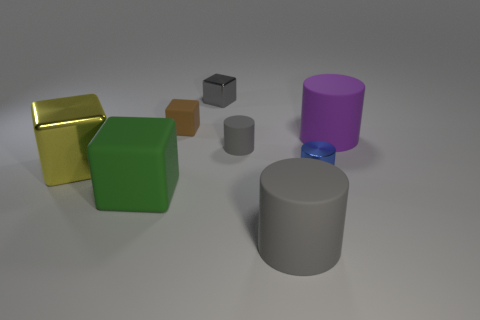There is a brown block that is the same material as the tiny gray cylinder; what size is it?
Give a very brief answer. Small. Is the shape of the small gray rubber thing the same as the tiny matte thing left of the small rubber cylinder?
Your answer should be very brief. No. What is the size of the blue metallic cylinder?
Ensure brevity in your answer.  Small. Is the number of big things that are right of the big green rubber thing less than the number of brown things?
Keep it short and to the point. No. What number of red metal things have the same size as the shiny cylinder?
Offer a very short reply. 0. There is a big thing that is the same color as the small metal cube; what shape is it?
Your answer should be compact. Cylinder. Does the big cylinder behind the big gray thing have the same color as the small thing that is on the left side of the small gray metallic thing?
Offer a terse response. No. There is a yellow object; how many metal cubes are behind it?
Your response must be concise. 1. The metallic cube that is the same color as the small rubber cylinder is what size?
Give a very brief answer. Small. Is there a tiny brown shiny thing that has the same shape as the big yellow shiny thing?
Your answer should be very brief. No. 